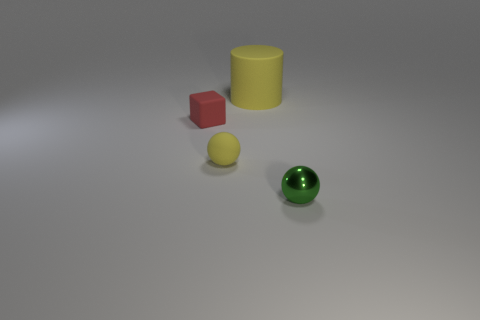Add 1 large brown blocks. How many objects exist? 5 Subtract all cylinders. How many objects are left? 3 Subtract 0 blue cubes. How many objects are left? 4 Subtract all yellow spheres. Subtract all small green metal objects. How many objects are left? 2 Add 4 spheres. How many spheres are left? 6 Add 3 yellow cylinders. How many yellow cylinders exist? 4 